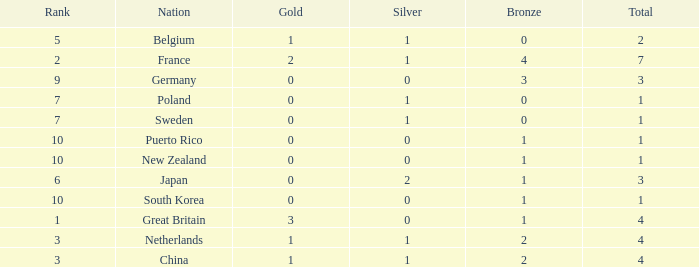What is the smallest number of gold where the total is less than 3 and the silver count is 2? None. 